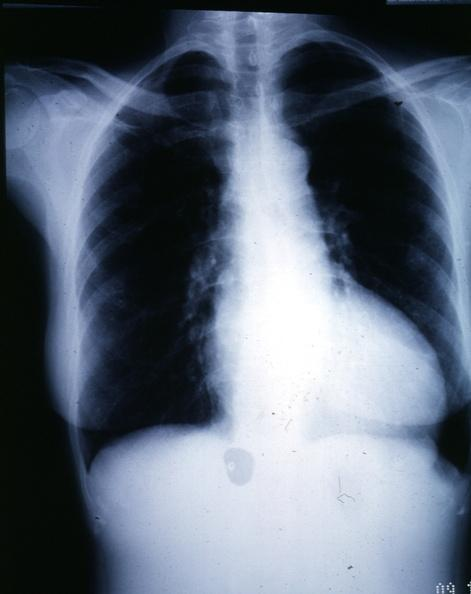what does this image show?
Answer the question using a single word or phrase. X-ray epa chest with obvious cardiomegaly female with aortic valve stenosis 